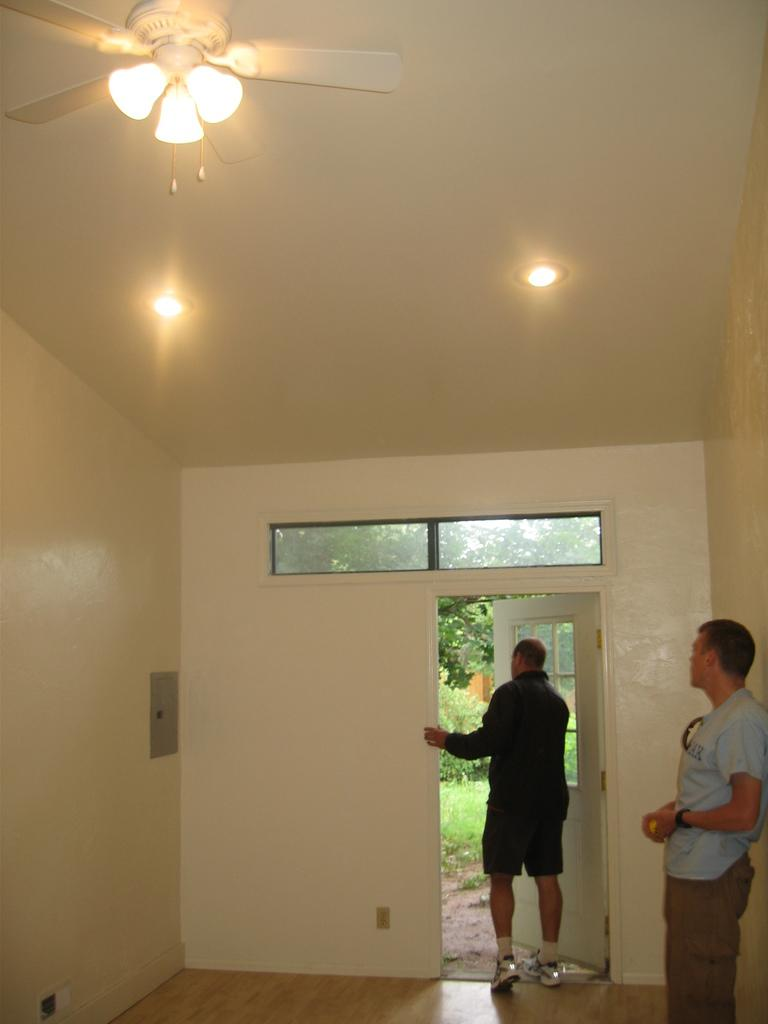How many people are present in the image? There are two people in the image. What can be seen in the background of the image? There is a door in the image. What type of lighting is present in the image? There are lights at the top of the image. What device is used for air circulation in the image? There is a fan visible in the image. What type of trees can be seen in the frame of the image? There are no trees visible in the image, and the term "frame" refers to the physical border of a photograph or painting, not a concept applicable to this image. 